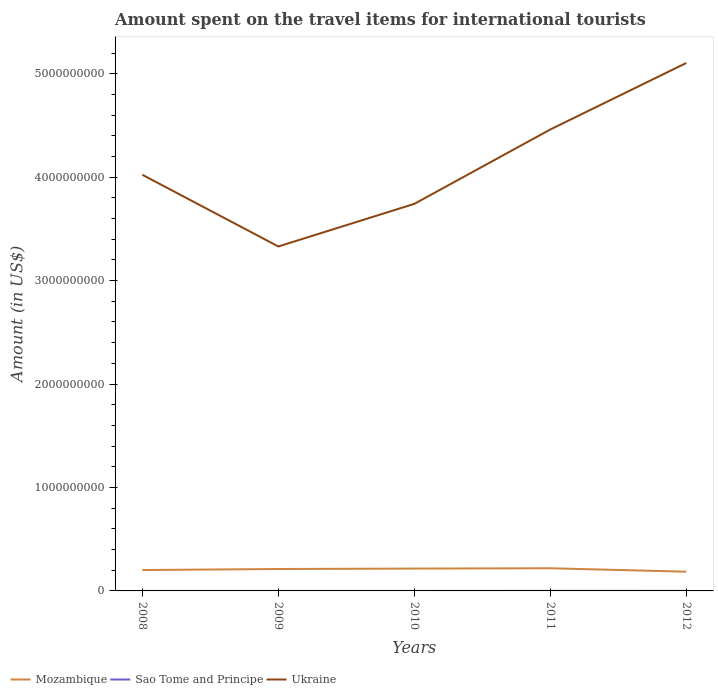How many different coloured lines are there?
Provide a succinct answer. 3. Is the number of lines equal to the number of legend labels?
Your answer should be very brief. Yes. Across all years, what is the maximum amount spent on the travel items for international tourists in Ukraine?
Your response must be concise. 3.33e+09. In which year was the amount spent on the travel items for international tourists in Mozambique maximum?
Your response must be concise. 2012. What is the total amount spent on the travel items for international tourists in Mozambique in the graph?
Provide a short and direct response. 1.60e+07. What is the difference between the highest and the second highest amount spent on the travel items for international tourists in Sao Tome and Principe?
Offer a very short reply. 6.30e+05. What is the difference between the highest and the lowest amount spent on the travel items for international tourists in Sao Tome and Principe?
Your response must be concise. 2. Is the amount spent on the travel items for international tourists in Mozambique strictly greater than the amount spent on the travel items for international tourists in Ukraine over the years?
Keep it short and to the point. Yes. How many lines are there?
Provide a succinct answer. 3. What is the difference between two consecutive major ticks on the Y-axis?
Ensure brevity in your answer.  1.00e+09. How are the legend labels stacked?
Give a very brief answer. Horizontal. What is the title of the graph?
Your answer should be very brief. Amount spent on the travel items for international tourists. Does "Nepal" appear as one of the legend labels in the graph?
Offer a terse response. No. What is the label or title of the X-axis?
Your answer should be very brief. Years. What is the Amount (in US$) of Mozambique in 2008?
Your response must be concise. 2.02e+08. What is the Amount (in US$) in Sao Tome and Principe in 2008?
Keep it short and to the point. 10000. What is the Amount (in US$) in Ukraine in 2008?
Offer a terse response. 4.02e+09. What is the Amount (in US$) in Mozambique in 2009?
Provide a short and direct response. 2.12e+08. What is the Amount (in US$) of Sao Tome and Principe in 2009?
Provide a short and direct response. 10000. What is the Amount (in US$) of Ukraine in 2009?
Provide a short and direct response. 3.33e+09. What is the Amount (in US$) of Mozambique in 2010?
Provide a short and direct response. 2.16e+08. What is the Amount (in US$) in Ukraine in 2010?
Provide a short and direct response. 3.74e+09. What is the Amount (in US$) of Mozambique in 2011?
Provide a short and direct response. 2.19e+08. What is the Amount (in US$) in Ukraine in 2011?
Your response must be concise. 4.46e+09. What is the Amount (in US$) in Mozambique in 2012?
Provide a short and direct response. 1.86e+08. What is the Amount (in US$) of Sao Tome and Principe in 2012?
Give a very brief answer. 6.40e+05. What is the Amount (in US$) in Ukraine in 2012?
Provide a short and direct response. 5.10e+09. Across all years, what is the maximum Amount (in US$) in Mozambique?
Provide a short and direct response. 2.19e+08. Across all years, what is the maximum Amount (in US$) in Sao Tome and Principe?
Your response must be concise. 6.40e+05. Across all years, what is the maximum Amount (in US$) in Ukraine?
Provide a short and direct response. 5.10e+09. Across all years, what is the minimum Amount (in US$) in Mozambique?
Ensure brevity in your answer.  1.86e+08. Across all years, what is the minimum Amount (in US$) of Ukraine?
Make the answer very short. 3.33e+09. What is the total Amount (in US$) in Mozambique in the graph?
Provide a succinct answer. 1.04e+09. What is the total Amount (in US$) of Sao Tome and Principe in the graph?
Your answer should be very brief. 1.06e+06. What is the total Amount (in US$) in Ukraine in the graph?
Ensure brevity in your answer.  2.07e+1. What is the difference between the Amount (in US$) of Mozambique in 2008 and that in 2009?
Provide a succinct answer. -1.00e+07. What is the difference between the Amount (in US$) of Ukraine in 2008 and that in 2009?
Give a very brief answer. 6.93e+08. What is the difference between the Amount (in US$) of Mozambique in 2008 and that in 2010?
Provide a short and direct response. -1.40e+07. What is the difference between the Amount (in US$) in Ukraine in 2008 and that in 2010?
Your answer should be very brief. 2.81e+08. What is the difference between the Amount (in US$) in Mozambique in 2008 and that in 2011?
Your answer should be very brief. -1.70e+07. What is the difference between the Amount (in US$) in Ukraine in 2008 and that in 2011?
Your answer should be very brief. -4.38e+08. What is the difference between the Amount (in US$) in Mozambique in 2008 and that in 2012?
Offer a very short reply. 1.60e+07. What is the difference between the Amount (in US$) in Sao Tome and Principe in 2008 and that in 2012?
Offer a terse response. -6.30e+05. What is the difference between the Amount (in US$) of Ukraine in 2008 and that in 2012?
Make the answer very short. -1.08e+09. What is the difference between the Amount (in US$) of Mozambique in 2009 and that in 2010?
Give a very brief answer. -4.00e+06. What is the difference between the Amount (in US$) in Ukraine in 2009 and that in 2010?
Offer a terse response. -4.12e+08. What is the difference between the Amount (in US$) in Mozambique in 2009 and that in 2011?
Your answer should be very brief. -7.00e+06. What is the difference between the Amount (in US$) in Ukraine in 2009 and that in 2011?
Your answer should be compact. -1.13e+09. What is the difference between the Amount (in US$) of Mozambique in 2009 and that in 2012?
Provide a short and direct response. 2.60e+07. What is the difference between the Amount (in US$) of Sao Tome and Principe in 2009 and that in 2012?
Keep it short and to the point. -6.30e+05. What is the difference between the Amount (in US$) of Ukraine in 2009 and that in 2012?
Your response must be concise. -1.77e+09. What is the difference between the Amount (in US$) of Mozambique in 2010 and that in 2011?
Your response must be concise. -3.00e+06. What is the difference between the Amount (in US$) in Sao Tome and Principe in 2010 and that in 2011?
Offer a very short reply. -3.00e+05. What is the difference between the Amount (in US$) of Ukraine in 2010 and that in 2011?
Keep it short and to the point. -7.19e+08. What is the difference between the Amount (in US$) in Mozambique in 2010 and that in 2012?
Give a very brief answer. 3.00e+07. What is the difference between the Amount (in US$) of Sao Tome and Principe in 2010 and that in 2012?
Offer a terse response. -5.90e+05. What is the difference between the Amount (in US$) of Ukraine in 2010 and that in 2012?
Keep it short and to the point. -1.36e+09. What is the difference between the Amount (in US$) of Mozambique in 2011 and that in 2012?
Offer a terse response. 3.30e+07. What is the difference between the Amount (in US$) of Ukraine in 2011 and that in 2012?
Your answer should be very brief. -6.43e+08. What is the difference between the Amount (in US$) of Mozambique in 2008 and the Amount (in US$) of Sao Tome and Principe in 2009?
Keep it short and to the point. 2.02e+08. What is the difference between the Amount (in US$) of Mozambique in 2008 and the Amount (in US$) of Ukraine in 2009?
Provide a short and direct response. -3.13e+09. What is the difference between the Amount (in US$) in Sao Tome and Principe in 2008 and the Amount (in US$) in Ukraine in 2009?
Your answer should be compact. -3.33e+09. What is the difference between the Amount (in US$) of Mozambique in 2008 and the Amount (in US$) of Sao Tome and Principe in 2010?
Offer a terse response. 2.02e+08. What is the difference between the Amount (in US$) of Mozambique in 2008 and the Amount (in US$) of Ukraine in 2010?
Your answer should be very brief. -3.54e+09. What is the difference between the Amount (in US$) in Sao Tome and Principe in 2008 and the Amount (in US$) in Ukraine in 2010?
Offer a terse response. -3.74e+09. What is the difference between the Amount (in US$) in Mozambique in 2008 and the Amount (in US$) in Sao Tome and Principe in 2011?
Ensure brevity in your answer.  2.02e+08. What is the difference between the Amount (in US$) in Mozambique in 2008 and the Amount (in US$) in Ukraine in 2011?
Your answer should be very brief. -4.26e+09. What is the difference between the Amount (in US$) of Sao Tome and Principe in 2008 and the Amount (in US$) of Ukraine in 2011?
Offer a very short reply. -4.46e+09. What is the difference between the Amount (in US$) in Mozambique in 2008 and the Amount (in US$) in Sao Tome and Principe in 2012?
Offer a terse response. 2.01e+08. What is the difference between the Amount (in US$) of Mozambique in 2008 and the Amount (in US$) of Ukraine in 2012?
Your answer should be very brief. -4.90e+09. What is the difference between the Amount (in US$) in Sao Tome and Principe in 2008 and the Amount (in US$) in Ukraine in 2012?
Provide a short and direct response. -5.10e+09. What is the difference between the Amount (in US$) of Mozambique in 2009 and the Amount (in US$) of Sao Tome and Principe in 2010?
Your response must be concise. 2.12e+08. What is the difference between the Amount (in US$) of Mozambique in 2009 and the Amount (in US$) of Ukraine in 2010?
Offer a very short reply. -3.53e+09. What is the difference between the Amount (in US$) of Sao Tome and Principe in 2009 and the Amount (in US$) of Ukraine in 2010?
Your answer should be very brief. -3.74e+09. What is the difference between the Amount (in US$) in Mozambique in 2009 and the Amount (in US$) in Sao Tome and Principe in 2011?
Give a very brief answer. 2.12e+08. What is the difference between the Amount (in US$) in Mozambique in 2009 and the Amount (in US$) in Ukraine in 2011?
Give a very brief answer. -4.25e+09. What is the difference between the Amount (in US$) of Sao Tome and Principe in 2009 and the Amount (in US$) of Ukraine in 2011?
Offer a terse response. -4.46e+09. What is the difference between the Amount (in US$) in Mozambique in 2009 and the Amount (in US$) in Sao Tome and Principe in 2012?
Provide a succinct answer. 2.11e+08. What is the difference between the Amount (in US$) of Mozambique in 2009 and the Amount (in US$) of Ukraine in 2012?
Your answer should be compact. -4.89e+09. What is the difference between the Amount (in US$) in Sao Tome and Principe in 2009 and the Amount (in US$) in Ukraine in 2012?
Keep it short and to the point. -5.10e+09. What is the difference between the Amount (in US$) of Mozambique in 2010 and the Amount (in US$) of Sao Tome and Principe in 2011?
Your answer should be very brief. 2.16e+08. What is the difference between the Amount (in US$) in Mozambique in 2010 and the Amount (in US$) in Ukraine in 2011?
Provide a succinct answer. -4.24e+09. What is the difference between the Amount (in US$) in Sao Tome and Principe in 2010 and the Amount (in US$) in Ukraine in 2011?
Provide a short and direct response. -4.46e+09. What is the difference between the Amount (in US$) of Mozambique in 2010 and the Amount (in US$) of Sao Tome and Principe in 2012?
Make the answer very short. 2.15e+08. What is the difference between the Amount (in US$) of Mozambique in 2010 and the Amount (in US$) of Ukraine in 2012?
Your response must be concise. -4.89e+09. What is the difference between the Amount (in US$) in Sao Tome and Principe in 2010 and the Amount (in US$) in Ukraine in 2012?
Keep it short and to the point. -5.10e+09. What is the difference between the Amount (in US$) in Mozambique in 2011 and the Amount (in US$) in Sao Tome and Principe in 2012?
Your answer should be compact. 2.18e+08. What is the difference between the Amount (in US$) in Mozambique in 2011 and the Amount (in US$) in Ukraine in 2012?
Make the answer very short. -4.88e+09. What is the difference between the Amount (in US$) of Sao Tome and Principe in 2011 and the Amount (in US$) of Ukraine in 2012?
Your response must be concise. -5.10e+09. What is the average Amount (in US$) in Mozambique per year?
Give a very brief answer. 2.07e+08. What is the average Amount (in US$) in Sao Tome and Principe per year?
Your response must be concise. 2.12e+05. What is the average Amount (in US$) in Ukraine per year?
Offer a very short reply. 4.13e+09. In the year 2008, what is the difference between the Amount (in US$) of Mozambique and Amount (in US$) of Sao Tome and Principe?
Give a very brief answer. 2.02e+08. In the year 2008, what is the difference between the Amount (in US$) in Mozambique and Amount (in US$) in Ukraine?
Make the answer very short. -3.82e+09. In the year 2008, what is the difference between the Amount (in US$) of Sao Tome and Principe and Amount (in US$) of Ukraine?
Keep it short and to the point. -4.02e+09. In the year 2009, what is the difference between the Amount (in US$) of Mozambique and Amount (in US$) of Sao Tome and Principe?
Provide a succinct answer. 2.12e+08. In the year 2009, what is the difference between the Amount (in US$) in Mozambique and Amount (in US$) in Ukraine?
Your response must be concise. -3.12e+09. In the year 2009, what is the difference between the Amount (in US$) in Sao Tome and Principe and Amount (in US$) in Ukraine?
Your answer should be compact. -3.33e+09. In the year 2010, what is the difference between the Amount (in US$) of Mozambique and Amount (in US$) of Sao Tome and Principe?
Provide a succinct answer. 2.16e+08. In the year 2010, what is the difference between the Amount (in US$) of Mozambique and Amount (in US$) of Ukraine?
Provide a succinct answer. -3.53e+09. In the year 2010, what is the difference between the Amount (in US$) of Sao Tome and Principe and Amount (in US$) of Ukraine?
Provide a short and direct response. -3.74e+09. In the year 2011, what is the difference between the Amount (in US$) in Mozambique and Amount (in US$) in Sao Tome and Principe?
Give a very brief answer. 2.19e+08. In the year 2011, what is the difference between the Amount (in US$) of Mozambique and Amount (in US$) of Ukraine?
Provide a short and direct response. -4.24e+09. In the year 2011, what is the difference between the Amount (in US$) of Sao Tome and Principe and Amount (in US$) of Ukraine?
Ensure brevity in your answer.  -4.46e+09. In the year 2012, what is the difference between the Amount (in US$) of Mozambique and Amount (in US$) of Sao Tome and Principe?
Offer a very short reply. 1.85e+08. In the year 2012, what is the difference between the Amount (in US$) of Mozambique and Amount (in US$) of Ukraine?
Your answer should be compact. -4.92e+09. In the year 2012, what is the difference between the Amount (in US$) in Sao Tome and Principe and Amount (in US$) in Ukraine?
Provide a succinct answer. -5.10e+09. What is the ratio of the Amount (in US$) of Mozambique in 2008 to that in 2009?
Keep it short and to the point. 0.95. What is the ratio of the Amount (in US$) in Ukraine in 2008 to that in 2009?
Your response must be concise. 1.21. What is the ratio of the Amount (in US$) in Mozambique in 2008 to that in 2010?
Provide a succinct answer. 0.94. What is the ratio of the Amount (in US$) in Sao Tome and Principe in 2008 to that in 2010?
Give a very brief answer. 0.2. What is the ratio of the Amount (in US$) of Ukraine in 2008 to that in 2010?
Make the answer very short. 1.08. What is the ratio of the Amount (in US$) in Mozambique in 2008 to that in 2011?
Provide a short and direct response. 0.92. What is the ratio of the Amount (in US$) of Sao Tome and Principe in 2008 to that in 2011?
Provide a succinct answer. 0.03. What is the ratio of the Amount (in US$) in Ukraine in 2008 to that in 2011?
Provide a succinct answer. 0.9. What is the ratio of the Amount (in US$) of Mozambique in 2008 to that in 2012?
Your answer should be very brief. 1.09. What is the ratio of the Amount (in US$) of Sao Tome and Principe in 2008 to that in 2012?
Your answer should be compact. 0.02. What is the ratio of the Amount (in US$) in Ukraine in 2008 to that in 2012?
Provide a succinct answer. 0.79. What is the ratio of the Amount (in US$) in Mozambique in 2009 to that in 2010?
Ensure brevity in your answer.  0.98. What is the ratio of the Amount (in US$) of Ukraine in 2009 to that in 2010?
Your answer should be very brief. 0.89. What is the ratio of the Amount (in US$) of Mozambique in 2009 to that in 2011?
Offer a very short reply. 0.97. What is the ratio of the Amount (in US$) of Sao Tome and Principe in 2009 to that in 2011?
Ensure brevity in your answer.  0.03. What is the ratio of the Amount (in US$) of Ukraine in 2009 to that in 2011?
Keep it short and to the point. 0.75. What is the ratio of the Amount (in US$) of Mozambique in 2009 to that in 2012?
Offer a very short reply. 1.14. What is the ratio of the Amount (in US$) in Sao Tome and Principe in 2009 to that in 2012?
Provide a succinct answer. 0.02. What is the ratio of the Amount (in US$) of Ukraine in 2009 to that in 2012?
Ensure brevity in your answer.  0.65. What is the ratio of the Amount (in US$) in Mozambique in 2010 to that in 2011?
Provide a succinct answer. 0.99. What is the ratio of the Amount (in US$) in Sao Tome and Principe in 2010 to that in 2011?
Offer a very short reply. 0.14. What is the ratio of the Amount (in US$) of Ukraine in 2010 to that in 2011?
Make the answer very short. 0.84. What is the ratio of the Amount (in US$) of Mozambique in 2010 to that in 2012?
Offer a very short reply. 1.16. What is the ratio of the Amount (in US$) of Sao Tome and Principe in 2010 to that in 2012?
Keep it short and to the point. 0.08. What is the ratio of the Amount (in US$) in Ukraine in 2010 to that in 2012?
Provide a short and direct response. 0.73. What is the ratio of the Amount (in US$) of Mozambique in 2011 to that in 2012?
Make the answer very short. 1.18. What is the ratio of the Amount (in US$) of Sao Tome and Principe in 2011 to that in 2012?
Your response must be concise. 0.55. What is the ratio of the Amount (in US$) in Ukraine in 2011 to that in 2012?
Your answer should be very brief. 0.87. What is the difference between the highest and the second highest Amount (in US$) of Mozambique?
Your answer should be very brief. 3.00e+06. What is the difference between the highest and the second highest Amount (in US$) in Sao Tome and Principe?
Provide a succinct answer. 2.90e+05. What is the difference between the highest and the second highest Amount (in US$) of Ukraine?
Provide a succinct answer. 6.43e+08. What is the difference between the highest and the lowest Amount (in US$) of Mozambique?
Give a very brief answer. 3.30e+07. What is the difference between the highest and the lowest Amount (in US$) of Sao Tome and Principe?
Your answer should be very brief. 6.30e+05. What is the difference between the highest and the lowest Amount (in US$) in Ukraine?
Your response must be concise. 1.77e+09. 